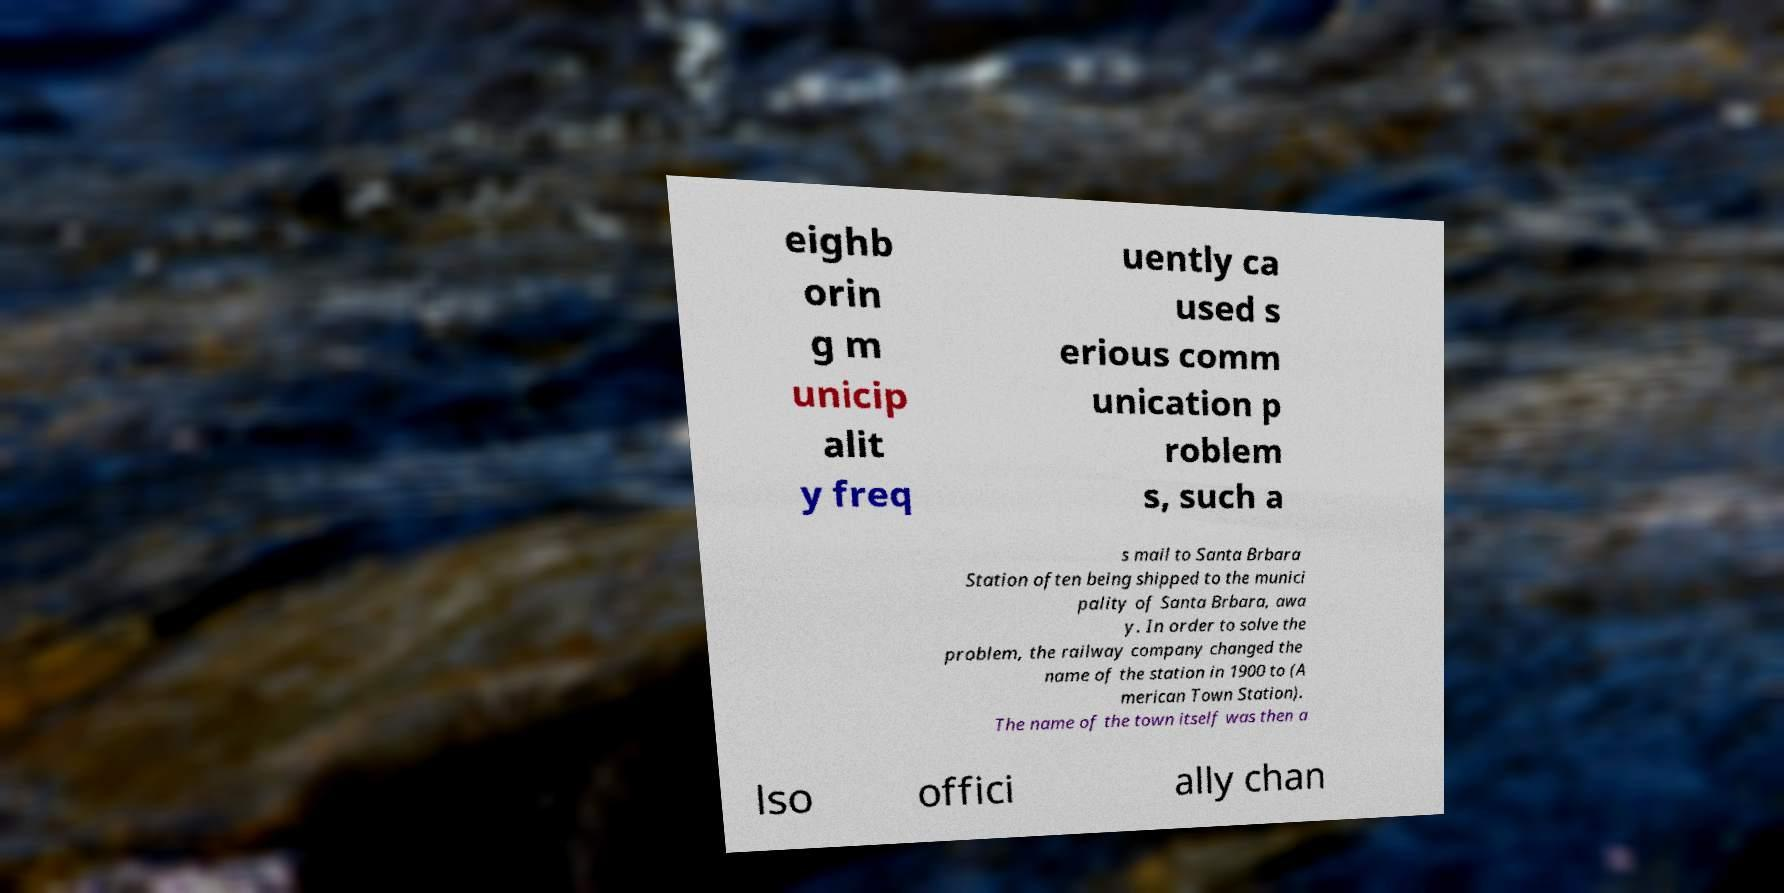Could you extract and type out the text from this image? eighb orin g m unicip alit y freq uently ca used s erious comm unication p roblem s, such a s mail to Santa Brbara Station often being shipped to the munici pality of Santa Brbara, awa y. In order to solve the problem, the railway company changed the name of the station in 1900 to (A merican Town Station). The name of the town itself was then a lso offici ally chan 